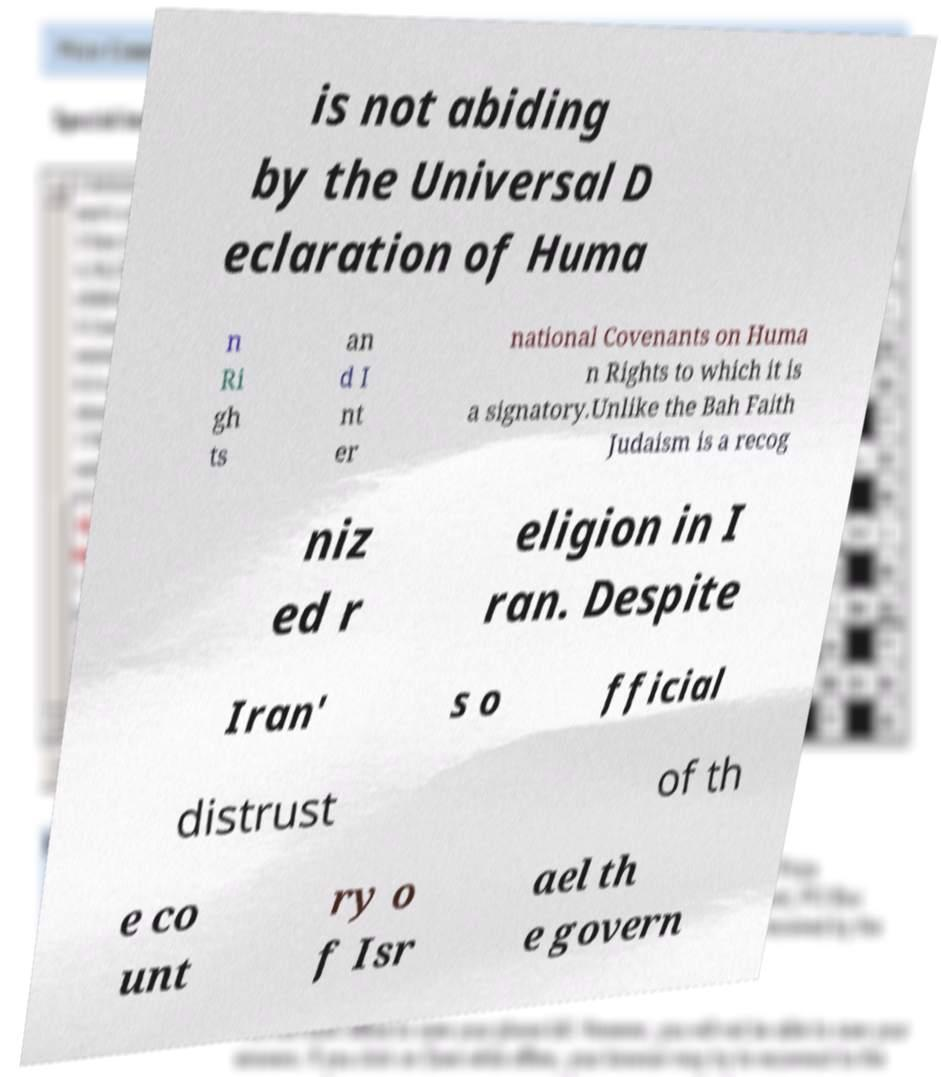There's text embedded in this image that I need extracted. Can you transcribe it verbatim? is not abiding by the Universal D eclaration of Huma n Ri gh ts an d I nt er national Covenants on Huma n Rights to which it is a signatory.Unlike the Bah Faith Judaism is a recog niz ed r eligion in I ran. Despite Iran' s o fficial distrust of th e co unt ry o f Isr ael th e govern 